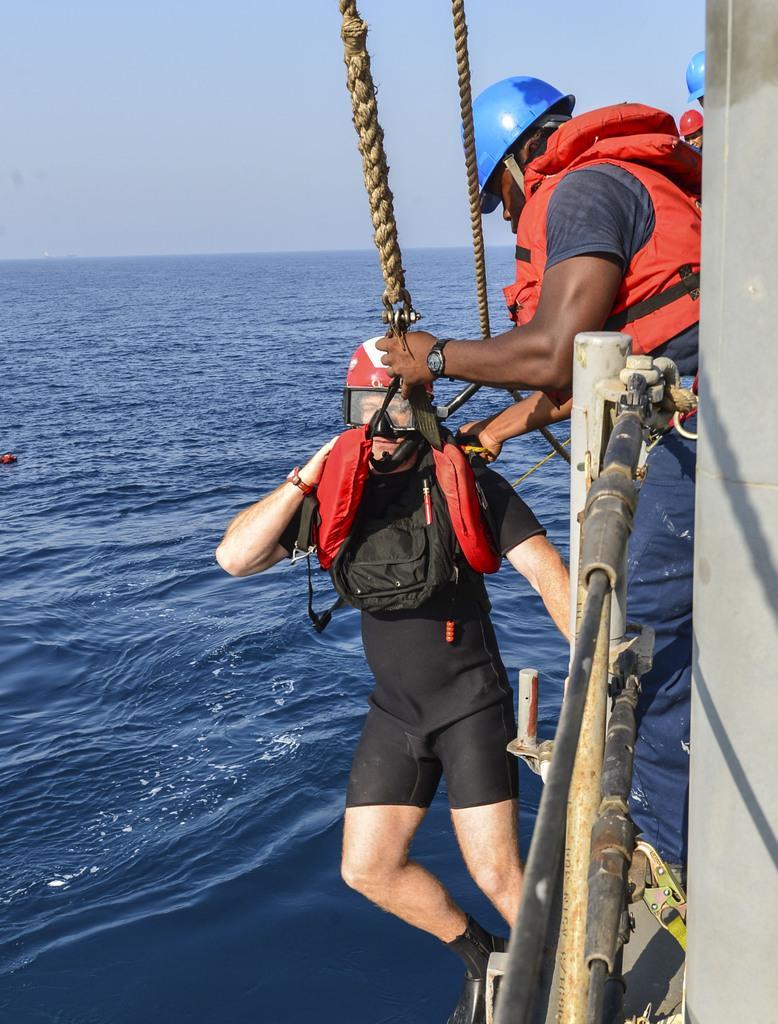How would you summarize this image in a sentence or two? This image consists of swim jackets and helmets. On the left, the man is being hanged with a rope. At the bottom, there is water. On the right, it looks like a ship. At the top, we can see the sky. 